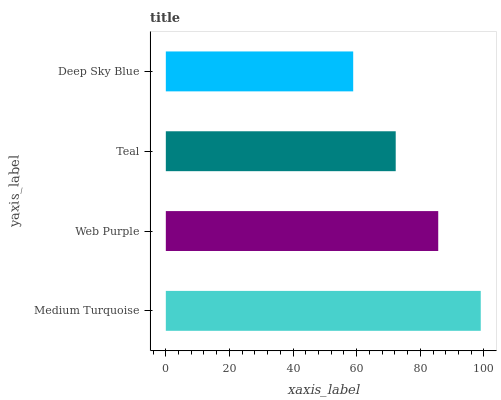Is Deep Sky Blue the minimum?
Answer yes or no. Yes. Is Medium Turquoise the maximum?
Answer yes or no. Yes. Is Web Purple the minimum?
Answer yes or no. No. Is Web Purple the maximum?
Answer yes or no. No. Is Medium Turquoise greater than Web Purple?
Answer yes or no. Yes. Is Web Purple less than Medium Turquoise?
Answer yes or no. Yes. Is Web Purple greater than Medium Turquoise?
Answer yes or no. No. Is Medium Turquoise less than Web Purple?
Answer yes or no. No. Is Web Purple the high median?
Answer yes or no. Yes. Is Teal the low median?
Answer yes or no. Yes. Is Medium Turquoise the high median?
Answer yes or no. No. Is Medium Turquoise the low median?
Answer yes or no. No. 